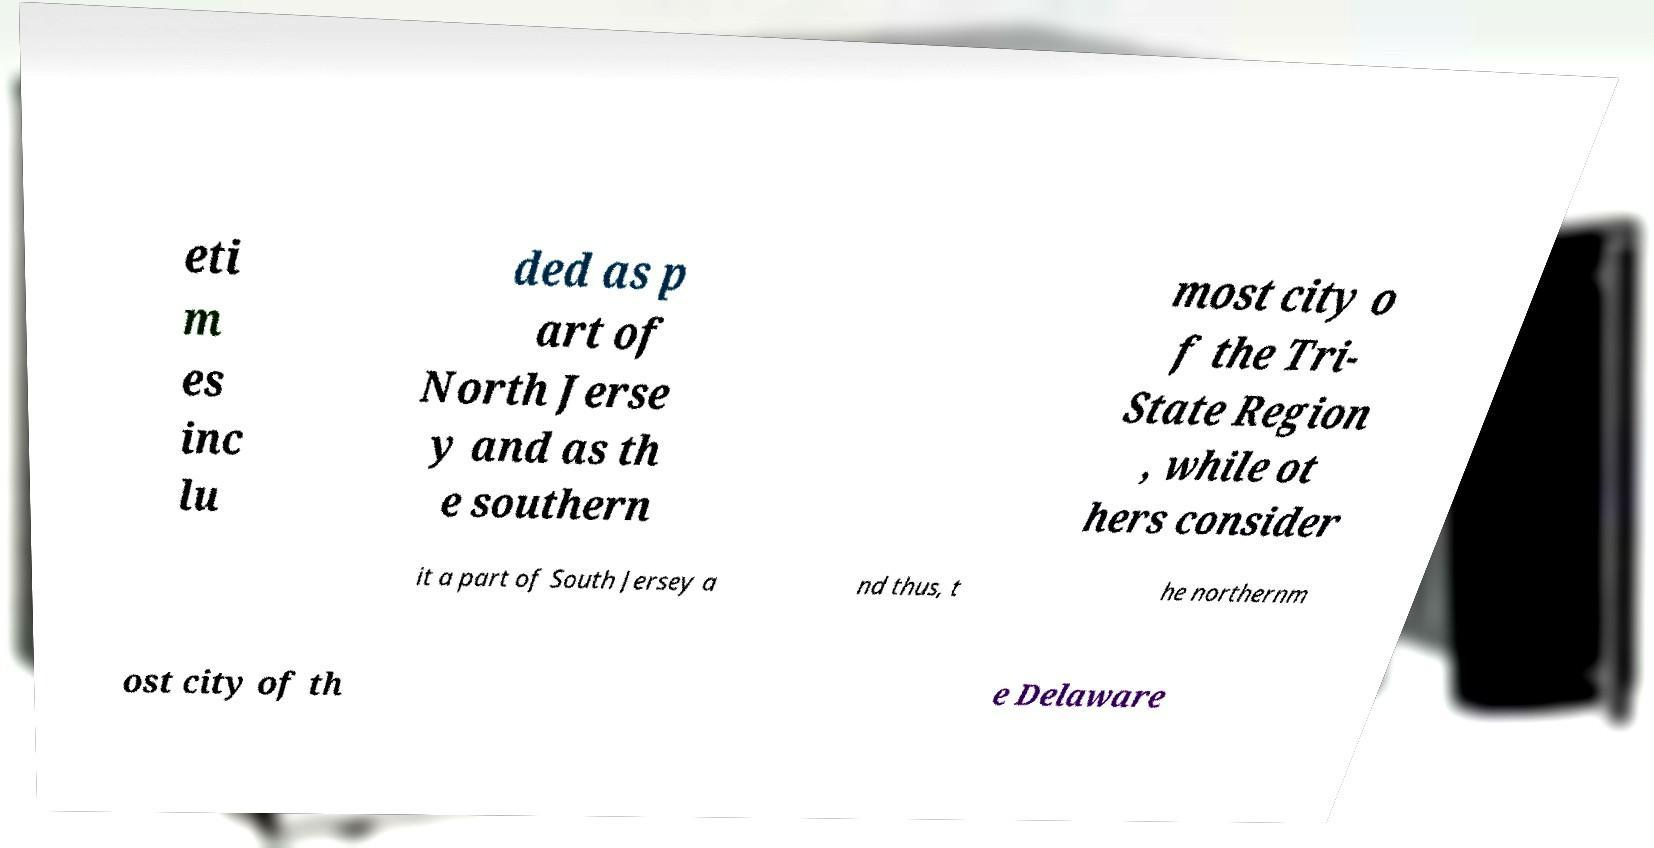For documentation purposes, I need the text within this image transcribed. Could you provide that? eti m es inc lu ded as p art of North Jerse y and as th e southern most city o f the Tri- State Region , while ot hers consider it a part of South Jersey a nd thus, t he northernm ost city of th e Delaware 